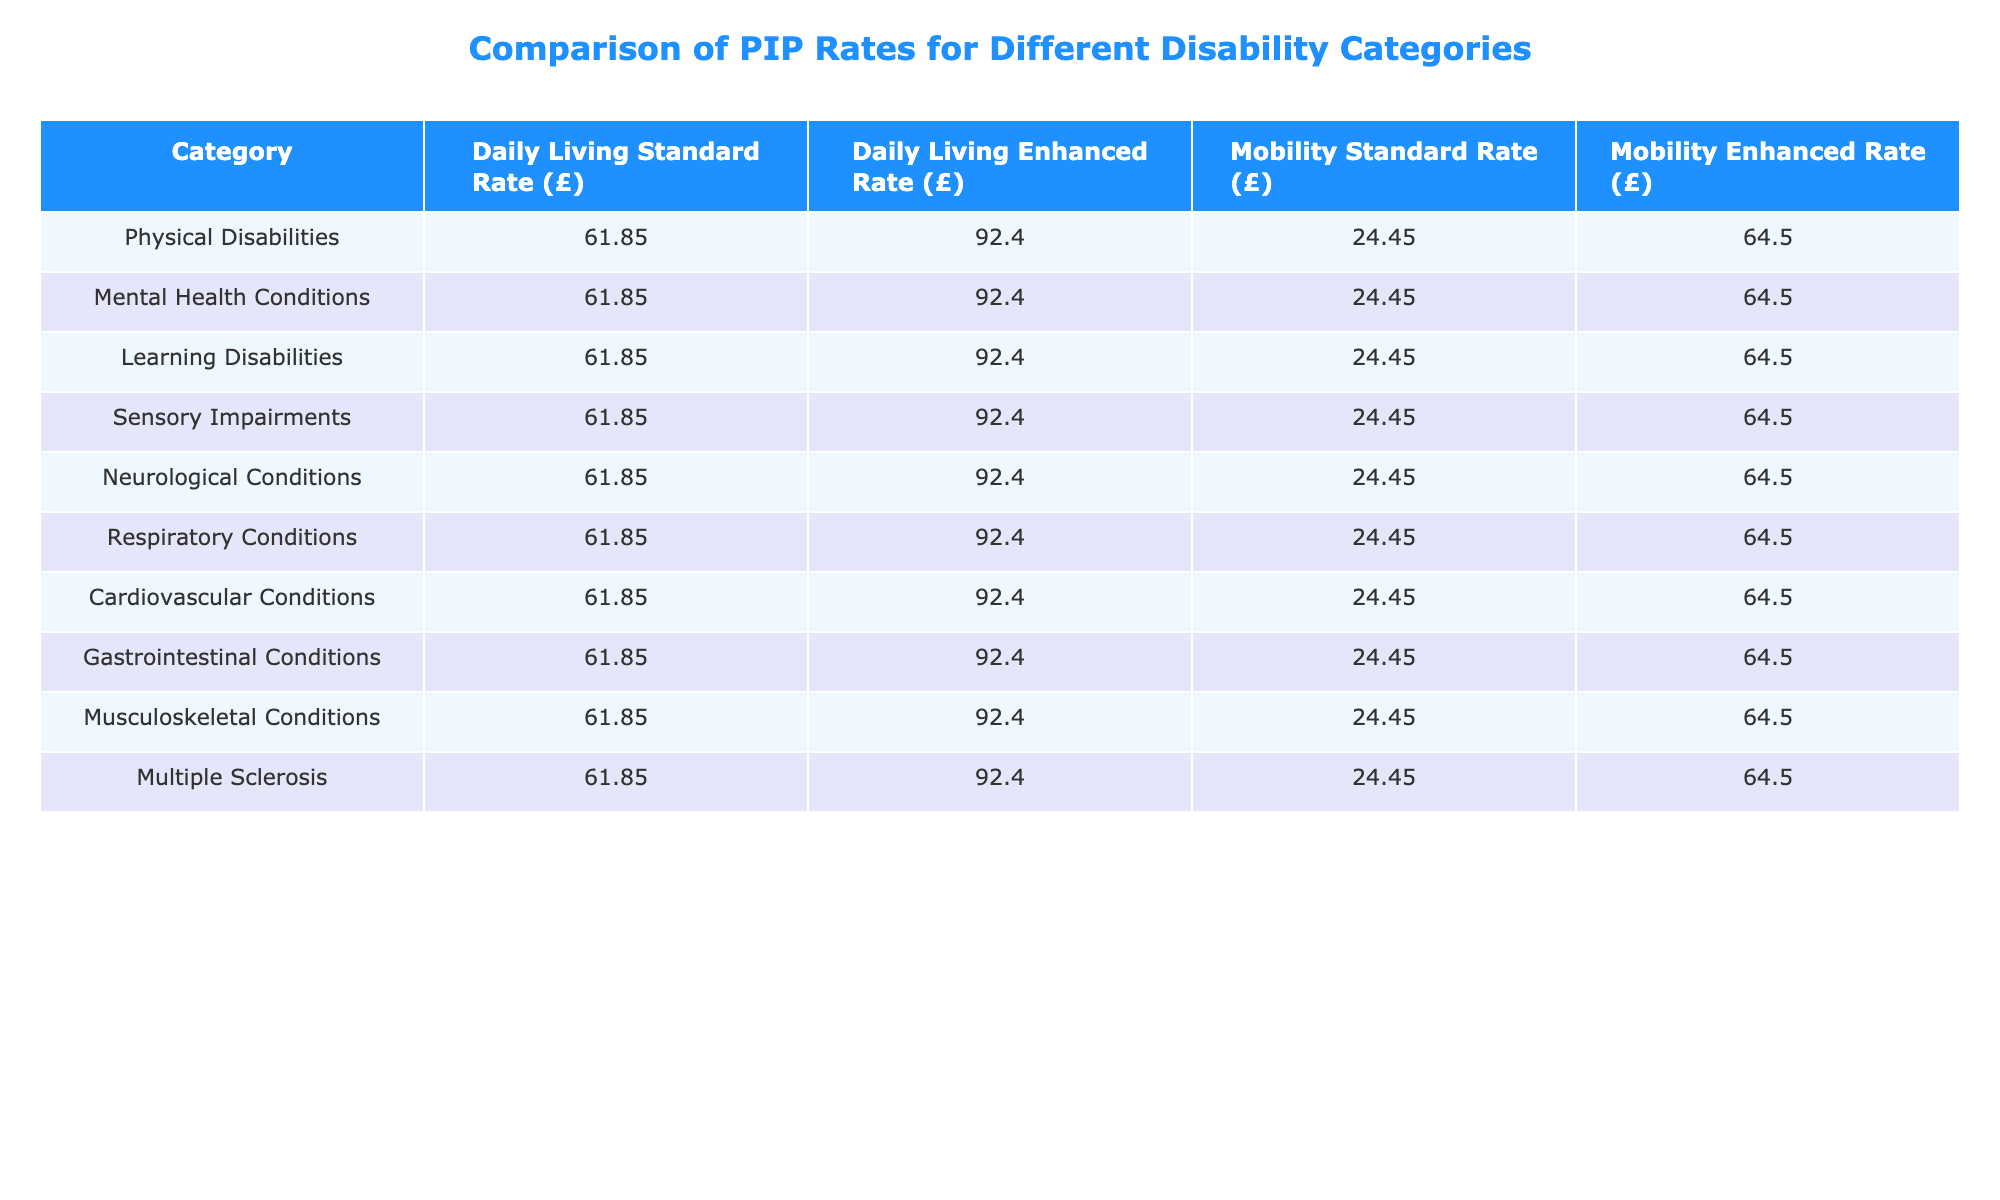What is the Daily Living Standard Rate for Physical Disabilities? The Daily Living Standard Rate for Physical Disabilities is found directly in the table under that specific category. It shows a value of £61.85.
Answer: £61.85 What is the difference between the Daily Living Enhanced Rate and the Mobility Standard Rate for Mental Health Conditions? The Daily Living Enhanced Rate for Mental Health Conditions is £92.40, and the Mobility Standard Rate is £24.45. To find the difference, subtract the two values: £92.40 - £24.45 = £67.95.
Answer: £67.95 Are all disability categories receiving the same Daily Living and Mobility rates? Looking across all categories in the table, the Daily Living Standard Rate and Enhanced Rate are consistently £61.85 and £92.40 respectively. Similarly, the Mobility Standard Rate and Enhanced Rate are £24.45 and £64.50. Therefore, yes, all categories receive the same rates.
Answer: Yes What is the total amount received from both Daily Living Enhanced Rate and Mobility Enhanced Rate for Neurological Conditions? For Neurological Conditions, the Daily Living Enhanced Rate is £92.40, and the Mobility Enhanced Rate is £64.50. To find the total, add the two amounts: £92.40 + £64.50 = £156.90.
Answer: £156.90 Is the Mobility Enhanced Rate for Sensory Impairments the same as for any other disability category? The table shows that the Mobility Enhanced Rate for Sensory Impairments is £64.50. Checking other categories, it is the same for Physical Disabilities, Mental Health Conditions, Learning Disabilities, Neurological Conditions, and others. Therefore, yes, it is the same across multiple categories.
Answer: Yes What is the average Daily Living Enhanced Rate across all disability categories listed? The Daily Living Enhanced Rate has a consistent value of £92.40 across all 10 disability categories. To find the average, we can simply note that since all values are the same, the average is also £92.40.
Answer: £92.40 Which disability category has the highest Daily Living Standard Rate? All disability categories listed show the same Daily Living Standard Rate of £61.85, so no specific category has a higher rate than the others.
Answer: None, all are the same How much more does someone with a Mobility Enhanced Rate receive compared to someone with a Mobility Standard Rate in any category? The Mobility Enhanced Rate is £64.50, and the Mobility Standard Rate is £24.45. The difference is £64.50 - £24.45 = £40.05. This calculation applies to any category, as the rates are consistent.
Answer: £40.05 